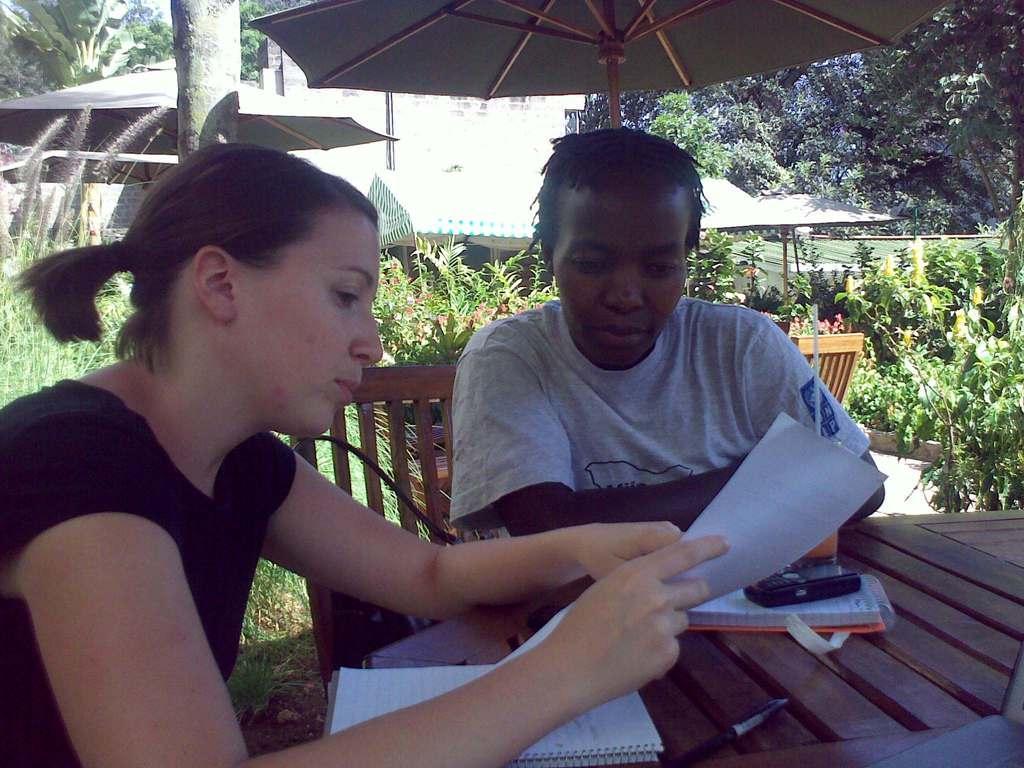Please provide a concise description of this image. In this picture we have women and a man. The woman is looking at the paper in her hand and there is a notebook in front of her, There is a table in front of her also there is a mobile phone on the table. In the background there is an umbrella, plants and a building. 